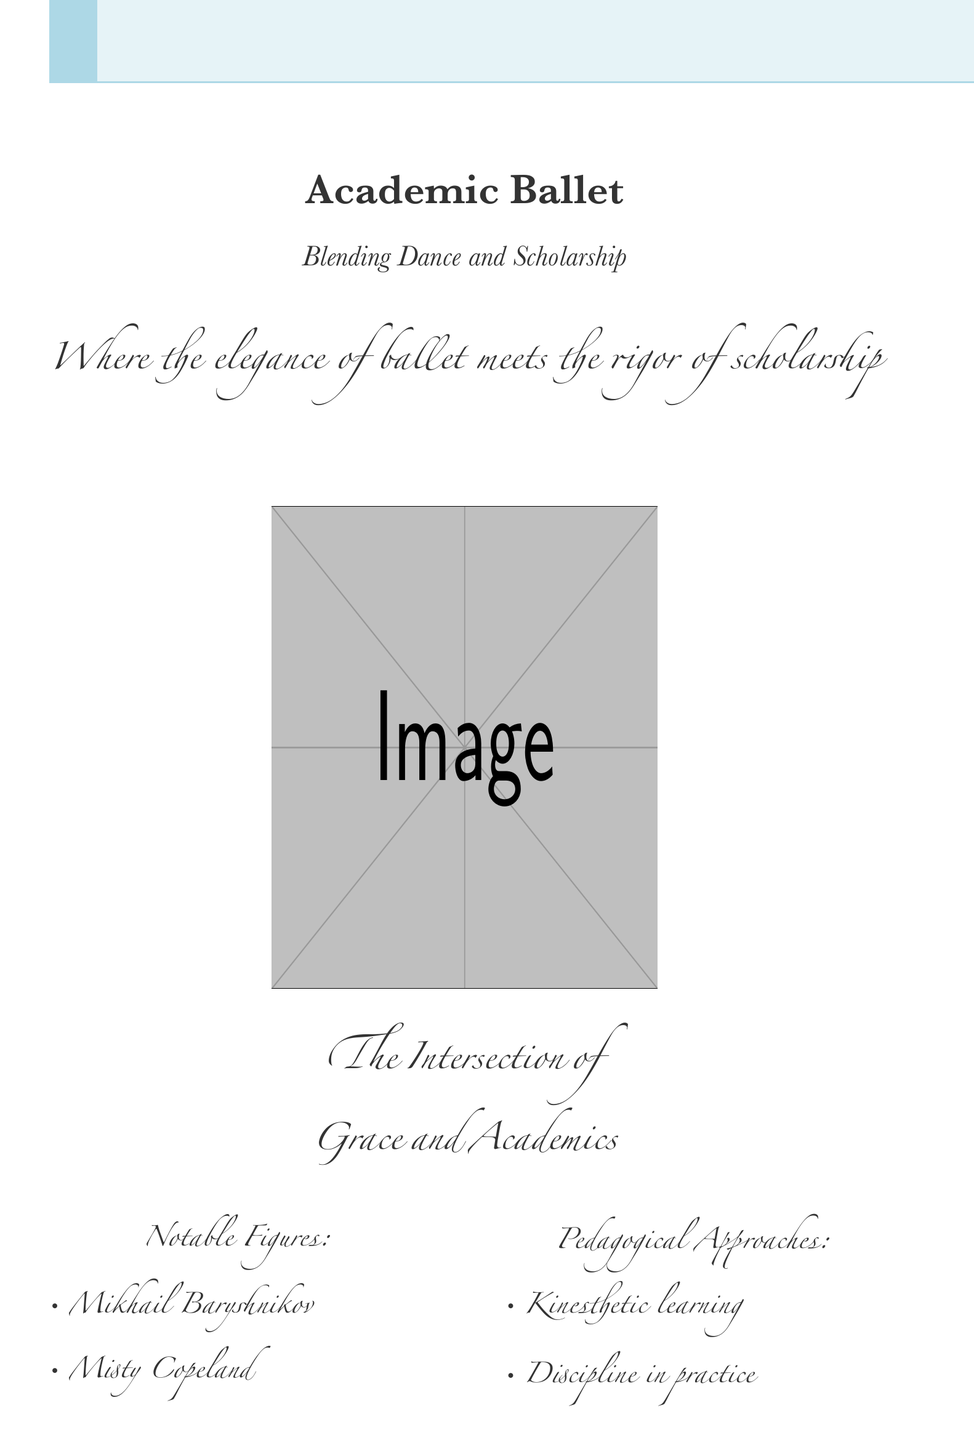What is the title of the book? The title is prominently displayed at the top of the cover.
Answer: Academic Ballet Who are the notable figures mentioned? The document lists notable figures in the context of dance.
Answer: Mikhail Baryshnikov, Misty Copeland What pedagogical approach is suggested in the document? The document outlines educational methodologies related to dance.
Answer: Kinesthetic learning What does the tagline say? The tagline is a phrase that captures the essence of the book, located beneath the title.
Answer: Where the elegance of ballet meets the rigor of scholarship What type of learners is this book aimed at? The intended audience is indicated towards the bottom of the cover.
Answer: Dance students, instructors, and academic researchers What is the color of the background? The color of the background is an important aspect of the cover design.
Answer: Pastel blue How is the relationship between ballet and scholarship described? This relationship is expressed in the tagline under the title.
Answer: The Intersection of Grace and Academics What font style is used for the title? The title's font choice contributes to the cover's aesthetic.
Answer: Baskerville How many figures are listed in the notable figures section? The number of persons mentioned provides insight into the relevance of the individuals included.
Answer: Two 